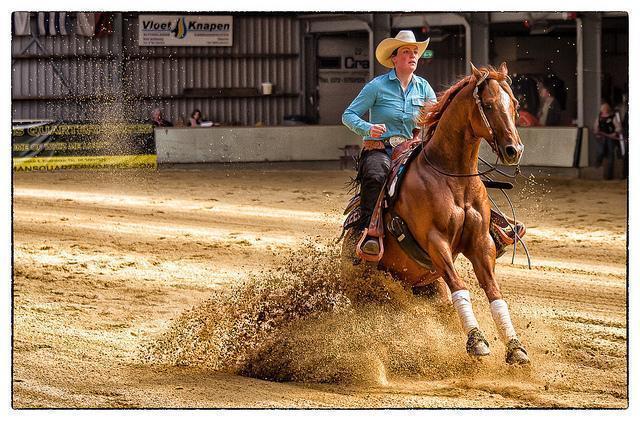Why is the horse on the the ground?
Select the correct answer and articulate reasoning with the following format: 'Answer: answer
Rationale: rationale.'
Options: Resting, getting even, fell, backing up. Answer: fell.
Rationale: It looks like the horse lost traction by the dirt being kicked up and it falling makes the most sense. 